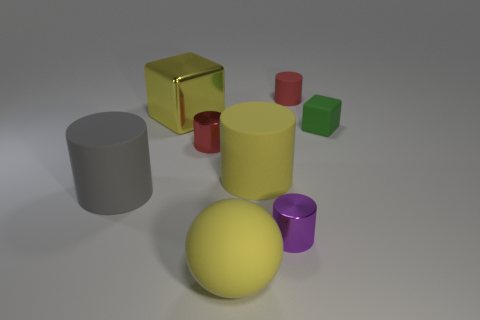Subtract all purple cylinders. How many cylinders are left? 4 Subtract all blue cylinders. Subtract all yellow spheres. How many cylinders are left? 5 Add 1 large yellow blocks. How many objects exist? 9 Subtract all spheres. How many objects are left? 7 Subtract 0 blue spheres. How many objects are left? 8 Subtract all large cyan rubber things. Subtract all small green blocks. How many objects are left? 7 Add 3 small red shiny cylinders. How many small red shiny cylinders are left? 4 Add 3 small green rubber cubes. How many small green rubber cubes exist? 4 